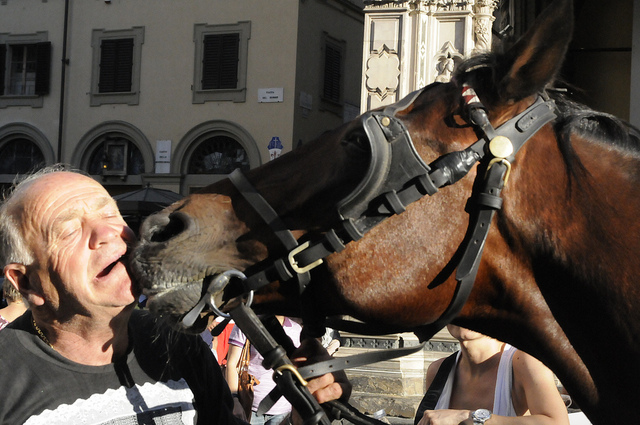<image>What is the position of the person riding the horse? I don't know the position of the person riding the horse. They could be standing or straight but it is also possible that they are out of view. What is the position of the person riding the horse? I don't know the position of the person riding the horse. It can be standing, delivery, out of view or pedestrian. 